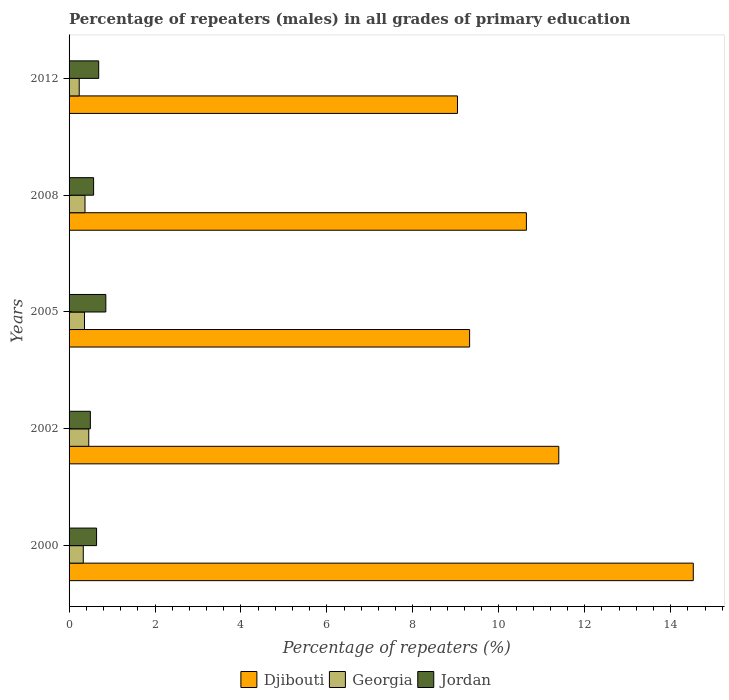Are the number of bars per tick equal to the number of legend labels?
Keep it short and to the point. Yes. Are the number of bars on each tick of the Y-axis equal?
Offer a terse response. Yes. How many bars are there on the 2nd tick from the top?
Make the answer very short. 3. What is the label of the 4th group of bars from the top?
Keep it short and to the point. 2002. What is the percentage of repeaters (males) in Djibouti in 2012?
Your answer should be very brief. 9.04. Across all years, what is the maximum percentage of repeaters (males) in Jordan?
Provide a short and direct response. 0.86. Across all years, what is the minimum percentage of repeaters (males) in Georgia?
Make the answer very short. 0.24. In which year was the percentage of repeaters (males) in Djibouti maximum?
Offer a very short reply. 2000. In which year was the percentage of repeaters (males) in Djibouti minimum?
Provide a succinct answer. 2012. What is the total percentage of repeaters (males) in Georgia in the graph?
Your response must be concise. 1.76. What is the difference between the percentage of repeaters (males) in Georgia in 2005 and that in 2008?
Your answer should be compact. -0.01. What is the difference between the percentage of repeaters (males) in Djibouti in 2005 and the percentage of repeaters (males) in Jordan in 2002?
Offer a very short reply. 8.82. What is the average percentage of repeaters (males) in Georgia per year?
Your response must be concise. 0.35. In the year 2008, what is the difference between the percentage of repeaters (males) in Georgia and percentage of repeaters (males) in Jordan?
Ensure brevity in your answer.  -0.2. What is the ratio of the percentage of repeaters (males) in Jordan in 2002 to that in 2008?
Give a very brief answer. 0.87. Is the difference between the percentage of repeaters (males) in Georgia in 2002 and 2008 greater than the difference between the percentage of repeaters (males) in Jordan in 2002 and 2008?
Offer a terse response. Yes. What is the difference between the highest and the second highest percentage of repeaters (males) in Georgia?
Ensure brevity in your answer.  0.09. What is the difference between the highest and the lowest percentage of repeaters (males) in Djibouti?
Keep it short and to the point. 5.49. In how many years, is the percentage of repeaters (males) in Djibouti greater than the average percentage of repeaters (males) in Djibouti taken over all years?
Make the answer very short. 2. Is the sum of the percentage of repeaters (males) in Georgia in 2002 and 2005 greater than the maximum percentage of repeaters (males) in Jordan across all years?
Provide a succinct answer. No. What does the 1st bar from the top in 2000 represents?
Your answer should be very brief. Jordan. What does the 2nd bar from the bottom in 2005 represents?
Provide a short and direct response. Georgia. Is it the case that in every year, the sum of the percentage of repeaters (males) in Georgia and percentage of repeaters (males) in Djibouti is greater than the percentage of repeaters (males) in Jordan?
Your answer should be very brief. Yes. How many bars are there?
Offer a terse response. 15. Are all the bars in the graph horizontal?
Ensure brevity in your answer.  Yes. What is the difference between two consecutive major ticks on the X-axis?
Keep it short and to the point. 2. Are the values on the major ticks of X-axis written in scientific E-notation?
Offer a very short reply. No. Where does the legend appear in the graph?
Give a very brief answer. Bottom center. What is the title of the graph?
Provide a short and direct response. Percentage of repeaters (males) in all grades of primary education. What is the label or title of the X-axis?
Keep it short and to the point. Percentage of repeaters (%). What is the Percentage of repeaters (%) of Djibouti in 2000?
Offer a very short reply. 14.52. What is the Percentage of repeaters (%) in Georgia in 2000?
Your answer should be compact. 0.33. What is the Percentage of repeaters (%) of Jordan in 2000?
Your answer should be very brief. 0.64. What is the Percentage of repeaters (%) in Djibouti in 2002?
Offer a very short reply. 11.39. What is the Percentage of repeaters (%) of Georgia in 2002?
Provide a short and direct response. 0.46. What is the Percentage of repeaters (%) in Jordan in 2002?
Offer a terse response. 0.5. What is the Percentage of repeaters (%) in Djibouti in 2005?
Your response must be concise. 9.32. What is the Percentage of repeaters (%) in Georgia in 2005?
Provide a short and direct response. 0.36. What is the Percentage of repeaters (%) of Jordan in 2005?
Offer a very short reply. 0.86. What is the Percentage of repeaters (%) in Djibouti in 2008?
Your response must be concise. 10.64. What is the Percentage of repeaters (%) in Georgia in 2008?
Your response must be concise. 0.37. What is the Percentage of repeaters (%) of Jordan in 2008?
Keep it short and to the point. 0.57. What is the Percentage of repeaters (%) in Djibouti in 2012?
Keep it short and to the point. 9.04. What is the Percentage of repeaters (%) of Georgia in 2012?
Offer a very short reply. 0.24. What is the Percentage of repeaters (%) of Jordan in 2012?
Your answer should be compact. 0.69. Across all years, what is the maximum Percentage of repeaters (%) of Djibouti?
Make the answer very short. 14.52. Across all years, what is the maximum Percentage of repeaters (%) of Georgia?
Give a very brief answer. 0.46. Across all years, what is the maximum Percentage of repeaters (%) in Jordan?
Keep it short and to the point. 0.86. Across all years, what is the minimum Percentage of repeaters (%) in Djibouti?
Your response must be concise. 9.04. Across all years, what is the minimum Percentage of repeaters (%) of Georgia?
Give a very brief answer. 0.24. Across all years, what is the minimum Percentage of repeaters (%) of Jordan?
Provide a short and direct response. 0.5. What is the total Percentage of repeaters (%) in Djibouti in the graph?
Offer a terse response. 54.92. What is the total Percentage of repeaters (%) in Georgia in the graph?
Your answer should be compact. 1.75. What is the total Percentage of repeaters (%) in Jordan in the graph?
Offer a very short reply. 3.25. What is the difference between the Percentage of repeaters (%) of Djibouti in 2000 and that in 2002?
Your answer should be very brief. 3.13. What is the difference between the Percentage of repeaters (%) of Georgia in 2000 and that in 2002?
Your response must be concise. -0.13. What is the difference between the Percentage of repeaters (%) in Jordan in 2000 and that in 2002?
Your response must be concise. 0.14. What is the difference between the Percentage of repeaters (%) of Djibouti in 2000 and that in 2005?
Provide a succinct answer. 5.2. What is the difference between the Percentage of repeaters (%) in Georgia in 2000 and that in 2005?
Give a very brief answer. -0.03. What is the difference between the Percentage of repeaters (%) in Jordan in 2000 and that in 2005?
Your answer should be compact. -0.22. What is the difference between the Percentage of repeaters (%) in Djibouti in 2000 and that in 2008?
Provide a succinct answer. 3.88. What is the difference between the Percentage of repeaters (%) in Georgia in 2000 and that in 2008?
Make the answer very short. -0.04. What is the difference between the Percentage of repeaters (%) in Jordan in 2000 and that in 2008?
Offer a terse response. 0.07. What is the difference between the Percentage of repeaters (%) of Djibouti in 2000 and that in 2012?
Provide a short and direct response. 5.49. What is the difference between the Percentage of repeaters (%) in Georgia in 2000 and that in 2012?
Provide a short and direct response. 0.09. What is the difference between the Percentage of repeaters (%) of Jordan in 2000 and that in 2012?
Provide a succinct answer. -0.05. What is the difference between the Percentage of repeaters (%) of Djibouti in 2002 and that in 2005?
Give a very brief answer. 2.07. What is the difference between the Percentage of repeaters (%) of Georgia in 2002 and that in 2005?
Ensure brevity in your answer.  0.1. What is the difference between the Percentage of repeaters (%) of Jordan in 2002 and that in 2005?
Your answer should be compact. -0.36. What is the difference between the Percentage of repeaters (%) in Djibouti in 2002 and that in 2008?
Provide a short and direct response. 0.75. What is the difference between the Percentage of repeaters (%) in Georgia in 2002 and that in 2008?
Ensure brevity in your answer.  0.09. What is the difference between the Percentage of repeaters (%) in Jordan in 2002 and that in 2008?
Offer a very short reply. -0.08. What is the difference between the Percentage of repeaters (%) in Djibouti in 2002 and that in 2012?
Offer a very short reply. 2.36. What is the difference between the Percentage of repeaters (%) in Georgia in 2002 and that in 2012?
Your answer should be compact. 0.22. What is the difference between the Percentage of repeaters (%) in Jordan in 2002 and that in 2012?
Your response must be concise. -0.19. What is the difference between the Percentage of repeaters (%) of Djibouti in 2005 and that in 2008?
Make the answer very short. -1.32. What is the difference between the Percentage of repeaters (%) of Georgia in 2005 and that in 2008?
Your response must be concise. -0.01. What is the difference between the Percentage of repeaters (%) in Jordan in 2005 and that in 2008?
Provide a short and direct response. 0.28. What is the difference between the Percentage of repeaters (%) in Djibouti in 2005 and that in 2012?
Ensure brevity in your answer.  0.28. What is the difference between the Percentage of repeaters (%) in Georgia in 2005 and that in 2012?
Ensure brevity in your answer.  0.12. What is the difference between the Percentage of repeaters (%) in Jordan in 2005 and that in 2012?
Offer a terse response. 0.17. What is the difference between the Percentage of repeaters (%) in Djibouti in 2008 and that in 2012?
Your response must be concise. 1.6. What is the difference between the Percentage of repeaters (%) in Georgia in 2008 and that in 2012?
Offer a very short reply. 0.13. What is the difference between the Percentage of repeaters (%) of Jordan in 2008 and that in 2012?
Ensure brevity in your answer.  -0.12. What is the difference between the Percentage of repeaters (%) of Djibouti in 2000 and the Percentage of repeaters (%) of Georgia in 2002?
Keep it short and to the point. 14.07. What is the difference between the Percentage of repeaters (%) in Djibouti in 2000 and the Percentage of repeaters (%) in Jordan in 2002?
Provide a succinct answer. 14.03. What is the difference between the Percentage of repeaters (%) in Georgia in 2000 and the Percentage of repeaters (%) in Jordan in 2002?
Give a very brief answer. -0.16. What is the difference between the Percentage of repeaters (%) in Djibouti in 2000 and the Percentage of repeaters (%) in Georgia in 2005?
Keep it short and to the point. 14.17. What is the difference between the Percentage of repeaters (%) in Djibouti in 2000 and the Percentage of repeaters (%) in Jordan in 2005?
Your answer should be compact. 13.67. What is the difference between the Percentage of repeaters (%) of Georgia in 2000 and the Percentage of repeaters (%) of Jordan in 2005?
Offer a terse response. -0.52. What is the difference between the Percentage of repeaters (%) of Djibouti in 2000 and the Percentage of repeaters (%) of Georgia in 2008?
Ensure brevity in your answer.  14.15. What is the difference between the Percentage of repeaters (%) of Djibouti in 2000 and the Percentage of repeaters (%) of Jordan in 2008?
Offer a terse response. 13.95. What is the difference between the Percentage of repeaters (%) of Georgia in 2000 and the Percentage of repeaters (%) of Jordan in 2008?
Give a very brief answer. -0.24. What is the difference between the Percentage of repeaters (%) in Djibouti in 2000 and the Percentage of repeaters (%) in Georgia in 2012?
Ensure brevity in your answer.  14.29. What is the difference between the Percentage of repeaters (%) of Djibouti in 2000 and the Percentage of repeaters (%) of Jordan in 2012?
Offer a terse response. 13.84. What is the difference between the Percentage of repeaters (%) of Georgia in 2000 and the Percentage of repeaters (%) of Jordan in 2012?
Provide a succinct answer. -0.36. What is the difference between the Percentage of repeaters (%) in Djibouti in 2002 and the Percentage of repeaters (%) in Georgia in 2005?
Offer a terse response. 11.04. What is the difference between the Percentage of repeaters (%) of Djibouti in 2002 and the Percentage of repeaters (%) of Jordan in 2005?
Keep it short and to the point. 10.54. What is the difference between the Percentage of repeaters (%) of Georgia in 2002 and the Percentage of repeaters (%) of Jordan in 2005?
Offer a very short reply. -0.4. What is the difference between the Percentage of repeaters (%) of Djibouti in 2002 and the Percentage of repeaters (%) of Georgia in 2008?
Your response must be concise. 11.02. What is the difference between the Percentage of repeaters (%) of Djibouti in 2002 and the Percentage of repeaters (%) of Jordan in 2008?
Offer a very short reply. 10.82. What is the difference between the Percentage of repeaters (%) of Georgia in 2002 and the Percentage of repeaters (%) of Jordan in 2008?
Offer a terse response. -0.11. What is the difference between the Percentage of repeaters (%) in Djibouti in 2002 and the Percentage of repeaters (%) in Georgia in 2012?
Give a very brief answer. 11.16. What is the difference between the Percentage of repeaters (%) of Djibouti in 2002 and the Percentage of repeaters (%) of Jordan in 2012?
Keep it short and to the point. 10.71. What is the difference between the Percentage of repeaters (%) in Georgia in 2002 and the Percentage of repeaters (%) in Jordan in 2012?
Provide a succinct answer. -0.23. What is the difference between the Percentage of repeaters (%) of Djibouti in 2005 and the Percentage of repeaters (%) of Georgia in 2008?
Give a very brief answer. 8.95. What is the difference between the Percentage of repeaters (%) of Djibouti in 2005 and the Percentage of repeaters (%) of Jordan in 2008?
Provide a succinct answer. 8.75. What is the difference between the Percentage of repeaters (%) of Georgia in 2005 and the Percentage of repeaters (%) of Jordan in 2008?
Offer a terse response. -0.21. What is the difference between the Percentage of repeaters (%) in Djibouti in 2005 and the Percentage of repeaters (%) in Georgia in 2012?
Offer a very short reply. 9.08. What is the difference between the Percentage of repeaters (%) of Djibouti in 2005 and the Percentage of repeaters (%) of Jordan in 2012?
Offer a terse response. 8.63. What is the difference between the Percentage of repeaters (%) in Georgia in 2005 and the Percentage of repeaters (%) in Jordan in 2012?
Your answer should be very brief. -0.33. What is the difference between the Percentage of repeaters (%) of Djibouti in 2008 and the Percentage of repeaters (%) of Georgia in 2012?
Keep it short and to the point. 10.41. What is the difference between the Percentage of repeaters (%) in Djibouti in 2008 and the Percentage of repeaters (%) in Jordan in 2012?
Keep it short and to the point. 9.95. What is the difference between the Percentage of repeaters (%) in Georgia in 2008 and the Percentage of repeaters (%) in Jordan in 2012?
Make the answer very short. -0.32. What is the average Percentage of repeaters (%) of Djibouti per year?
Provide a succinct answer. 10.98. What is the average Percentage of repeaters (%) of Georgia per year?
Ensure brevity in your answer.  0.35. What is the average Percentage of repeaters (%) in Jordan per year?
Offer a very short reply. 0.65. In the year 2000, what is the difference between the Percentage of repeaters (%) in Djibouti and Percentage of repeaters (%) in Georgia?
Offer a terse response. 14.19. In the year 2000, what is the difference between the Percentage of repeaters (%) in Djibouti and Percentage of repeaters (%) in Jordan?
Ensure brevity in your answer.  13.88. In the year 2000, what is the difference between the Percentage of repeaters (%) in Georgia and Percentage of repeaters (%) in Jordan?
Your answer should be very brief. -0.31. In the year 2002, what is the difference between the Percentage of repeaters (%) in Djibouti and Percentage of repeaters (%) in Georgia?
Your answer should be compact. 10.94. In the year 2002, what is the difference between the Percentage of repeaters (%) in Djibouti and Percentage of repeaters (%) in Jordan?
Your response must be concise. 10.9. In the year 2002, what is the difference between the Percentage of repeaters (%) of Georgia and Percentage of repeaters (%) of Jordan?
Your answer should be very brief. -0.04. In the year 2005, what is the difference between the Percentage of repeaters (%) in Djibouti and Percentage of repeaters (%) in Georgia?
Your response must be concise. 8.96. In the year 2005, what is the difference between the Percentage of repeaters (%) in Djibouti and Percentage of repeaters (%) in Jordan?
Give a very brief answer. 8.46. In the year 2005, what is the difference between the Percentage of repeaters (%) of Georgia and Percentage of repeaters (%) of Jordan?
Your answer should be compact. -0.5. In the year 2008, what is the difference between the Percentage of repeaters (%) of Djibouti and Percentage of repeaters (%) of Georgia?
Offer a terse response. 10.27. In the year 2008, what is the difference between the Percentage of repeaters (%) of Djibouti and Percentage of repeaters (%) of Jordan?
Provide a short and direct response. 10.07. In the year 2008, what is the difference between the Percentage of repeaters (%) in Georgia and Percentage of repeaters (%) in Jordan?
Ensure brevity in your answer.  -0.2. In the year 2012, what is the difference between the Percentage of repeaters (%) of Djibouti and Percentage of repeaters (%) of Georgia?
Your answer should be compact. 8.8. In the year 2012, what is the difference between the Percentage of repeaters (%) of Djibouti and Percentage of repeaters (%) of Jordan?
Keep it short and to the point. 8.35. In the year 2012, what is the difference between the Percentage of repeaters (%) of Georgia and Percentage of repeaters (%) of Jordan?
Keep it short and to the point. -0.45. What is the ratio of the Percentage of repeaters (%) of Djibouti in 2000 to that in 2002?
Offer a very short reply. 1.27. What is the ratio of the Percentage of repeaters (%) in Georgia in 2000 to that in 2002?
Ensure brevity in your answer.  0.72. What is the ratio of the Percentage of repeaters (%) of Jordan in 2000 to that in 2002?
Ensure brevity in your answer.  1.29. What is the ratio of the Percentage of repeaters (%) in Djibouti in 2000 to that in 2005?
Your answer should be compact. 1.56. What is the ratio of the Percentage of repeaters (%) of Georgia in 2000 to that in 2005?
Provide a short and direct response. 0.92. What is the ratio of the Percentage of repeaters (%) in Jordan in 2000 to that in 2005?
Provide a short and direct response. 0.75. What is the ratio of the Percentage of repeaters (%) of Djibouti in 2000 to that in 2008?
Ensure brevity in your answer.  1.36. What is the ratio of the Percentage of repeaters (%) of Georgia in 2000 to that in 2008?
Your response must be concise. 0.89. What is the ratio of the Percentage of repeaters (%) in Jordan in 2000 to that in 2008?
Provide a succinct answer. 1.12. What is the ratio of the Percentage of repeaters (%) in Djibouti in 2000 to that in 2012?
Make the answer very short. 1.61. What is the ratio of the Percentage of repeaters (%) of Georgia in 2000 to that in 2012?
Provide a short and direct response. 1.4. What is the ratio of the Percentage of repeaters (%) in Jordan in 2000 to that in 2012?
Offer a terse response. 0.93. What is the ratio of the Percentage of repeaters (%) in Djibouti in 2002 to that in 2005?
Ensure brevity in your answer.  1.22. What is the ratio of the Percentage of repeaters (%) in Georgia in 2002 to that in 2005?
Your response must be concise. 1.28. What is the ratio of the Percentage of repeaters (%) of Jordan in 2002 to that in 2005?
Keep it short and to the point. 0.58. What is the ratio of the Percentage of repeaters (%) of Djibouti in 2002 to that in 2008?
Keep it short and to the point. 1.07. What is the ratio of the Percentage of repeaters (%) in Georgia in 2002 to that in 2008?
Ensure brevity in your answer.  1.24. What is the ratio of the Percentage of repeaters (%) of Jordan in 2002 to that in 2008?
Your answer should be compact. 0.87. What is the ratio of the Percentage of repeaters (%) of Djibouti in 2002 to that in 2012?
Provide a succinct answer. 1.26. What is the ratio of the Percentage of repeaters (%) in Georgia in 2002 to that in 2012?
Your response must be concise. 1.94. What is the ratio of the Percentage of repeaters (%) in Jordan in 2002 to that in 2012?
Provide a succinct answer. 0.72. What is the ratio of the Percentage of repeaters (%) of Djibouti in 2005 to that in 2008?
Provide a short and direct response. 0.88. What is the ratio of the Percentage of repeaters (%) of Georgia in 2005 to that in 2008?
Offer a very short reply. 0.97. What is the ratio of the Percentage of repeaters (%) in Jordan in 2005 to that in 2008?
Make the answer very short. 1.5. What is the ratio of the Percentage of repeaters (%) of Djibouti in 2005 to that in 2012?
Your answer should be compact. 1.03. What is the ratio of the Percentage of repeaters (%) of Georgia in 2005 to that in 2012?
Keep it short and to the point. 1.52. What is the ratio of the Percentage of repeaters (%) in Jordan in 2005 to that in 2012?
Make the answer very short. 1.24. What is the ratio of the Percentage of repeaters (%) of Djibouti in 2008 to that in 2012?
Keep it short and to the point. 1.18. What is the ratio of the Percentage of repeaters (%) of Georgia in 2008 to that in 2012?
Provide a short and direct response. 1.57. What is the ratio of the Percentage of repeaters (%) in Jordan in 2008 to that in 2012?
Your answer should be very brief. 0.83. What is the difference between the highest and the second highest Percentage of repeaters (%) of Djibouti?
Your answer should be compact. 3.13. What is the difference between the highest and the second highest Percentage of repeaters (%) of Georgia?
Provide a succinct answer. 0.09. What is the difference between the highest and the second highest Percentage of repeaters (%) in Jordan?
Your response must be concise. 0.17. What is the difference between the highest and the lowest Percentage of repeaters (%) of Djibouti?
Provide a short and direct response. 5.49. What is the difference between the highest and the lowest Percentage of repeaters (%) in Georgia?
Offer a very short reply. 0.22. What is the difference between the highest and the lowest Percentage of repeaters (%) of Jordan?
Offer a terse response. 0.36. 